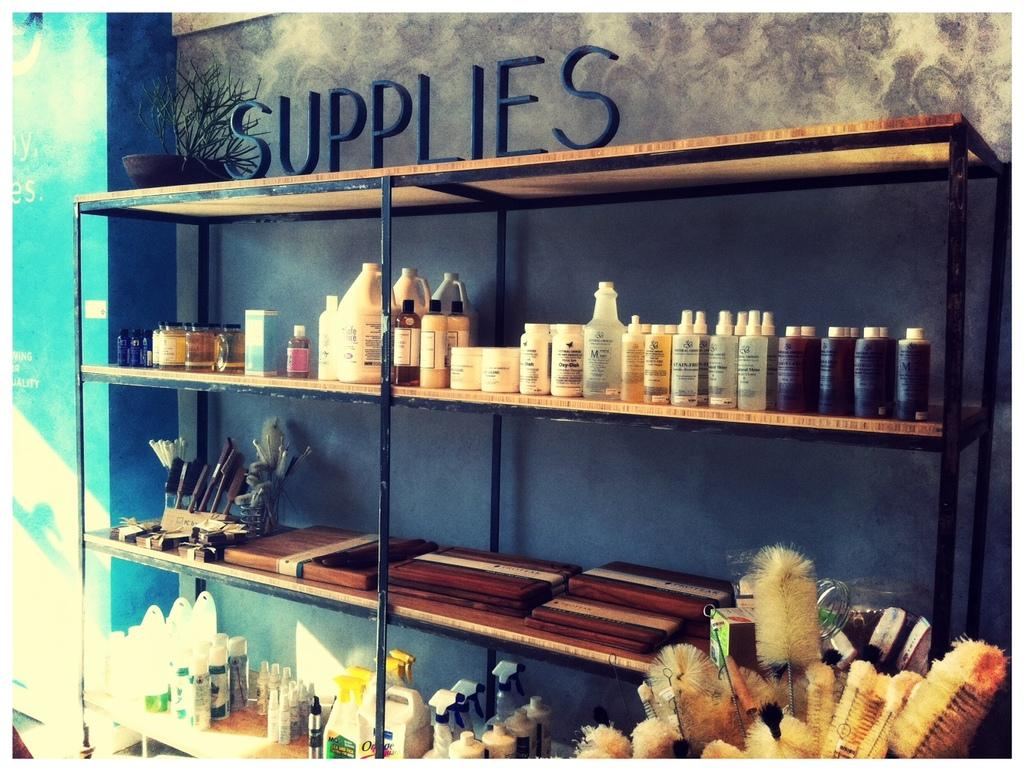<image>
Present a compact description of the photo's key features. Shelves labeled Supplies on the top have many bottles, vials, containers and brushes. 